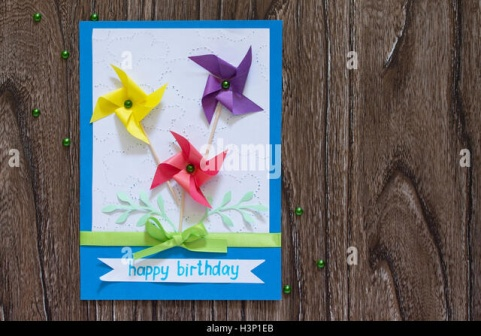Can you describe the materials and craftsmanship involved in making this birthday card? This delightful birthday card is a testament to skilled craftsmanship and creativity. The card itself is made from cardstock, providing a sturdy base for the decorations. The pinwheels are crafted from brightly colored paper, meticulously folded and affixed with small beads to represent the central pivots. These are attached to green paper stems cut and shaped to mimic natural plant stems, complete with tiny paper leaves. The intricate green foliage on the card's background is likely crafted using a technique such as stamping or detailed hand-painting. The central ribbon, with its neatly tied bow, appears to be made from satin or grosgrain, adding both texture and elegance. The 'happy birthday' greeting is written in a whimsical handwritten style, possibly hand-drawn or transferred using a crafting stencil or high-quality printer. Scattered green beads complete the design, adhered carefully to ensure they add a hint of sparkle without overpowering the main features. 